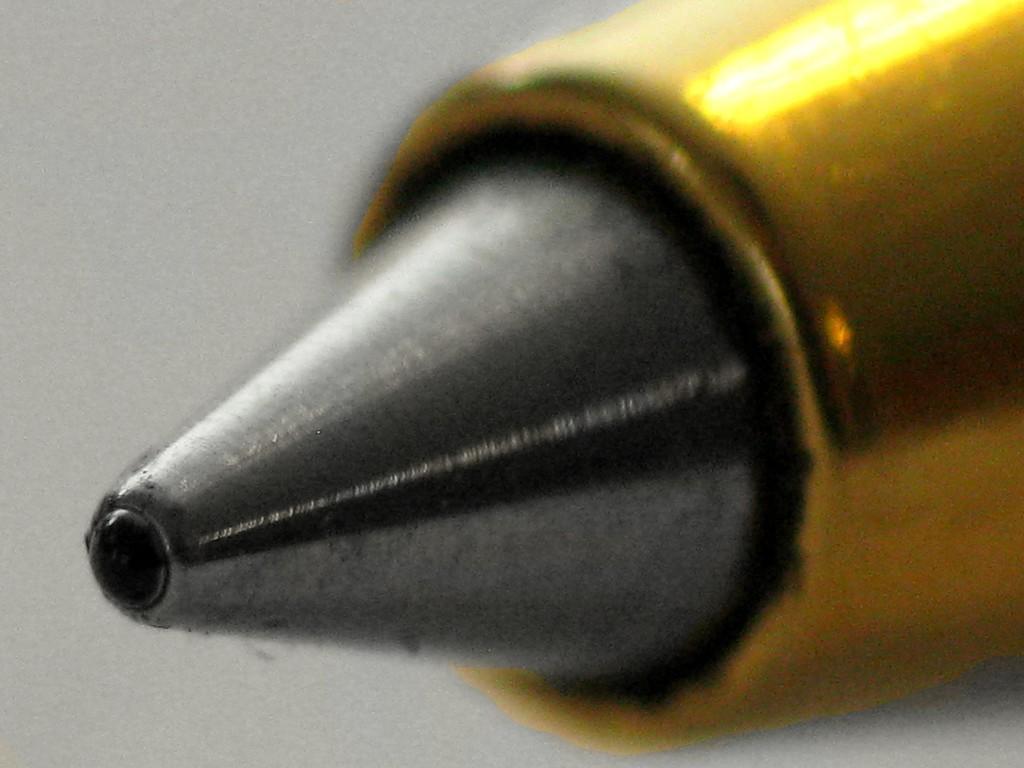How would you summarize this image in a sentence or two? In this image there is a metal object towards the right of the image that looks like a bullet, the background of the image is white in color. 